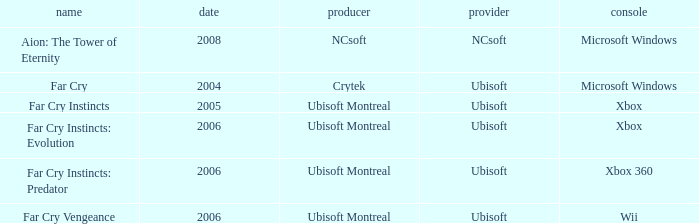What is the average year that has far cry vengeance as the title? 2006.0. 